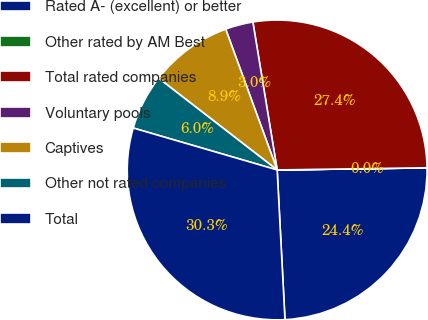<chart> <loc_0><loc_0><loc_500><loc_500><pie_chart><fcel>Rated A- (excellent) or better<fcel>Other rated by AM Best<fcel>Total rated companies<fcel>Voluntary pools<fcel>Captives<fcel>Other not rated companies<fcel>Total<nl><fcel>24.39%<fcel>0.01%<fcel>27.36%<fcel>2.99%<fcel>8.94%<fcel>5.97%<fcel>30.34%<nl></chart> 